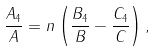Convert formula to latex. <formula><loc_0><loc_0><loc_500><loc_500>\frac { A _ { 4 } } { A } = n \left ( \frac { B _ { 4 } } { B } - \frac { C _ { 4 } } { C } \right ) ,</formula> 